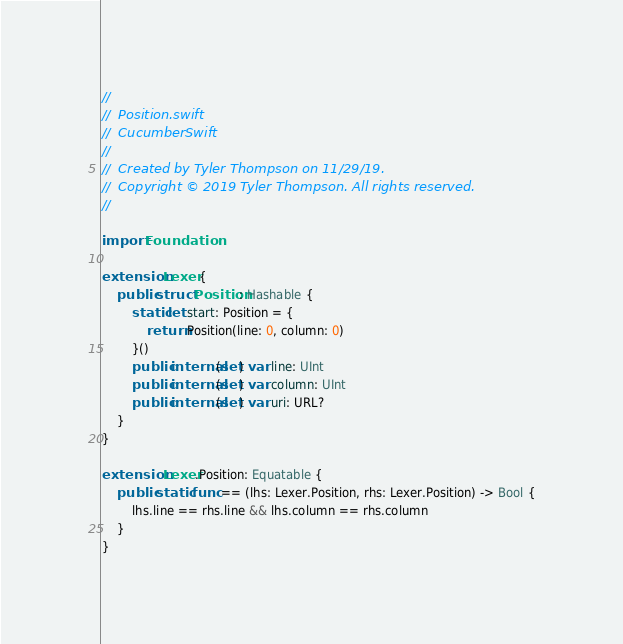Convert code to text. <code><loc_0><loc_0><loc_500><loc_500><_Swift_>//
//  Position.swift
//  CucumberSwift
//
//  Created by Tyler Thompson on 11/29/19.
//  Copyright © 2019 Tyler Thompson. All rights reserved.
//

import Foundation

extension Lexer {
    public struct Position: Hashable {
        static let start: Position = {
            return Position(line: 0, column: 0)
        }()
        public internal(set) var line: UInt
        public internal(set) var column: UInt
        public internal(set) var uri: URL?
    }
}

extension Lexer.Position: Equatable {
    public static func == (lhs: Lexer.Position, rhs: Lexer.Position) -> Bool {
        lhs.line == rhs.line && lhs.column == rhs.column
    }
}
</code> 